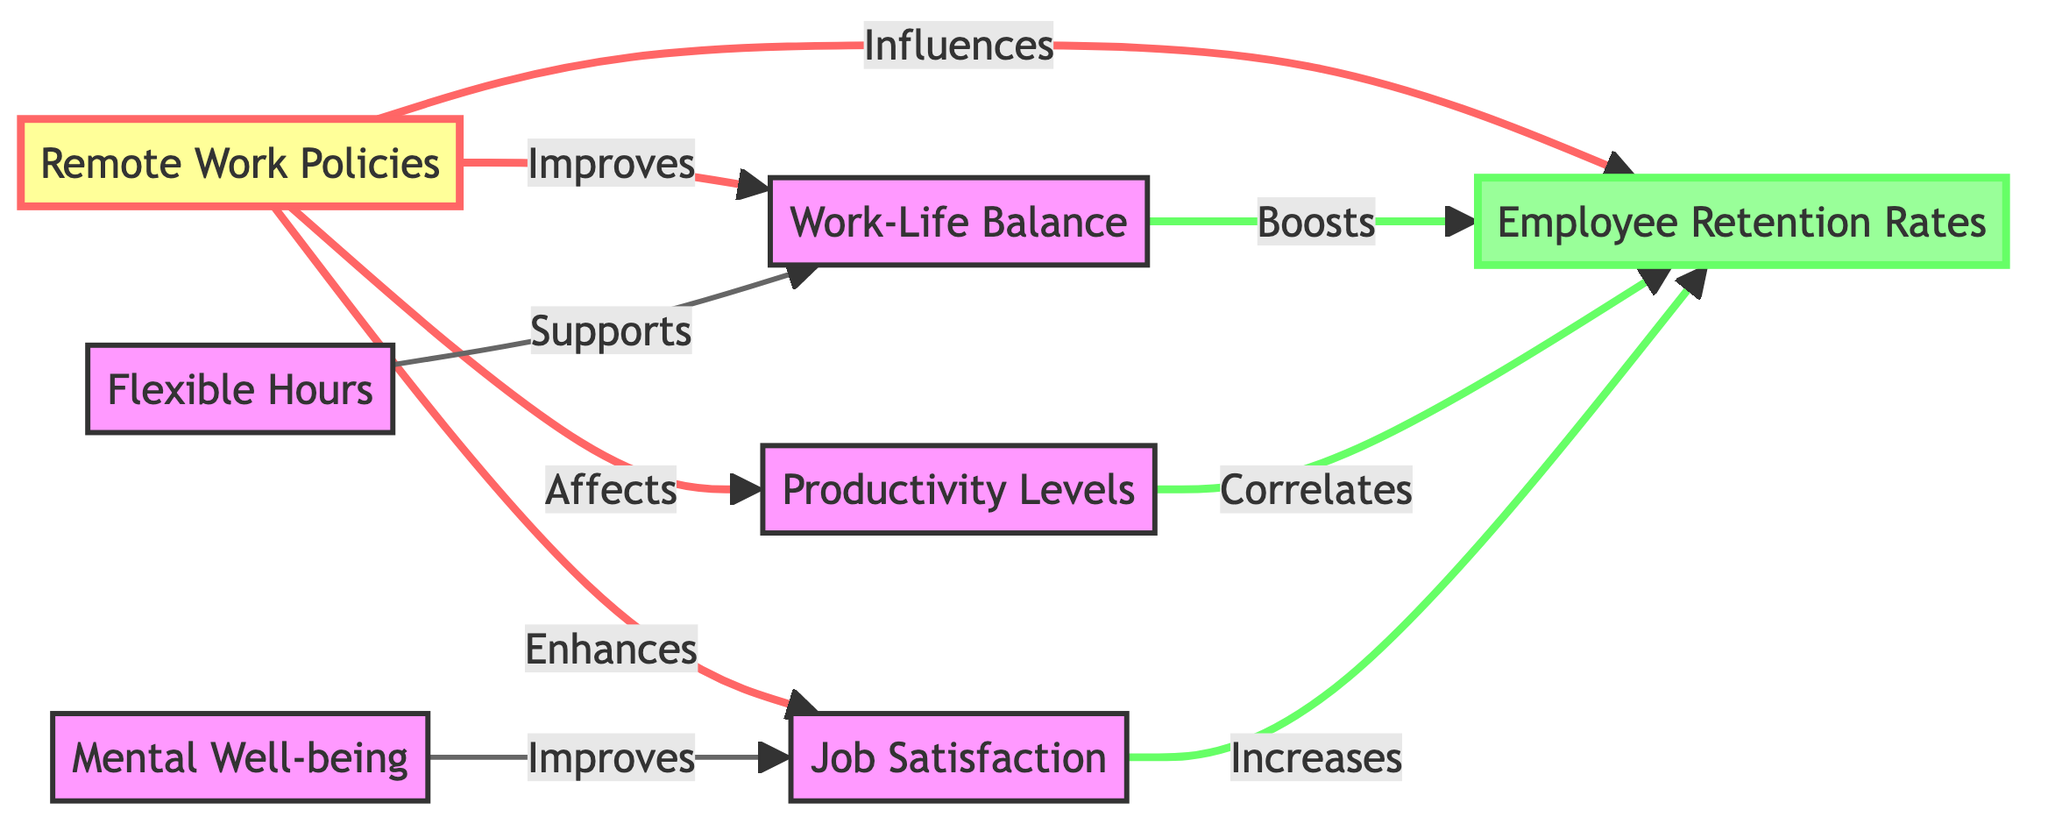What influences employee retention rates? According to the diagram, Remote Work Policies influence Employee Retention Rates, showing a direct connection between node A and node B.
Answer: Remote Work Policies How many factors are listed that enhance employee retention rates? The diagram shows three factors that enhance employee retention rates: Work-Life Balance, Productivity Levels, and Job Satisfaction. This can be observed by counting the nodes that flow into Employee Retention Rates from Work-Life Balance, Productivity Levels, and Job Satisfaction.
Answer: Three What supports work-life balance according to the diagram? The diagram indicates that Flexible Hours supports Work-Life Balance through a direct relationship between node F and node C.
Answer: Flexible Hours What is correlated with employee retention rates? The diagram indicates that both Productivity Levels and Job Satisfaction correlate with Employee Retention Rates, as depicted by the lines connecting nodes D and E to node B.
Answer: Productivity Levels and Job Satisfaction Which factor improves job satisfaction? The diagram states that Mental Well-being improves Job Satisfaction, showing a direct influence from node G to node E.
Answer: Mental Well-being What is the relationship between remote work policies and productivity levels? Remote Work Policies affect Productivity Levels as indicated by the direct connection from node A to node D. This signifies that changes in remote work policies can lead to variations in productivity levels.
Answer: Affects How do work-life balance and job satisfaction contribute to employee retention rates? The diagram illustrates that Work-Life Balance boosts Employee Retention Rates while Job Satisfaction increases them. This means that both factors contribute positively to retention rates, with direct connections from nodes C and E leading to node B, indicating their supportive relationship.
Answer: Boosts and Increases What effect do remote work policies have on work-life balance? The diagram clearly shows that Remote Work Policies improve Work-Life Balance through a direct relationship from node A to node C.
Answer: Improves What is the color coding for outcome classes in the diagram? In the diagram, the outcome nodes are colored in light green (#9f9) with a darker green stroke (#6f6), which distinguishes them from other types of nodes.
Answer: Light green and dark green 